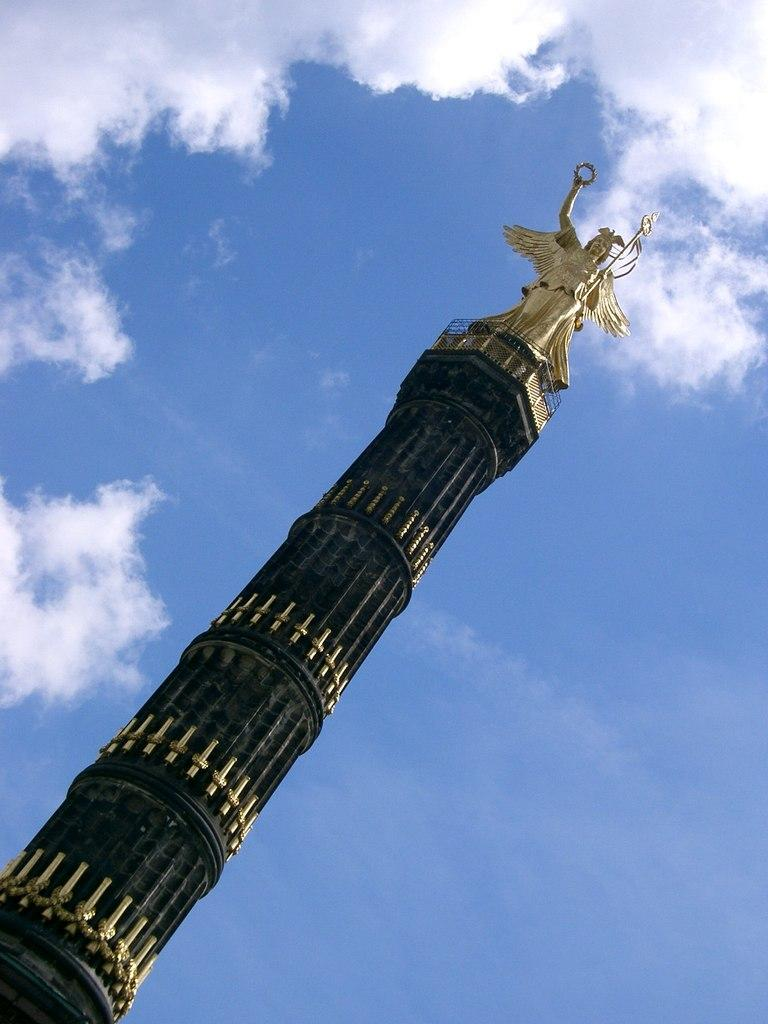What is the main structure in the image? There is a pillar in the image. What is on top of the pillar? There is a statue on the pillar. What can be seen in the background of the image? Sky is visible in the background of the image. What is the condition of the sky in the image? Clouds are present in the sky. What type of joke is being told by the statue in the image? There is no joke being told by the statue in the image; it is a stationary object. 